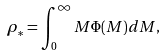<formula> <loc_0><loc_0><loc_500><loc_500>\rho _ { * } = \int _ { 0 } ^ { \infty } M \Phi ( M ) d M ,</formula> 